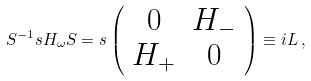<formula> <loc_0><loc_0><loc_500><loc_500>S ^ { - 1 } s H _ { \omega } S = s \left ( \begin{array} { c c } 0 & H _ { - } \\ H _ { + } & 0 \end{array} \right ) \equiv i L \, ,</formula> 